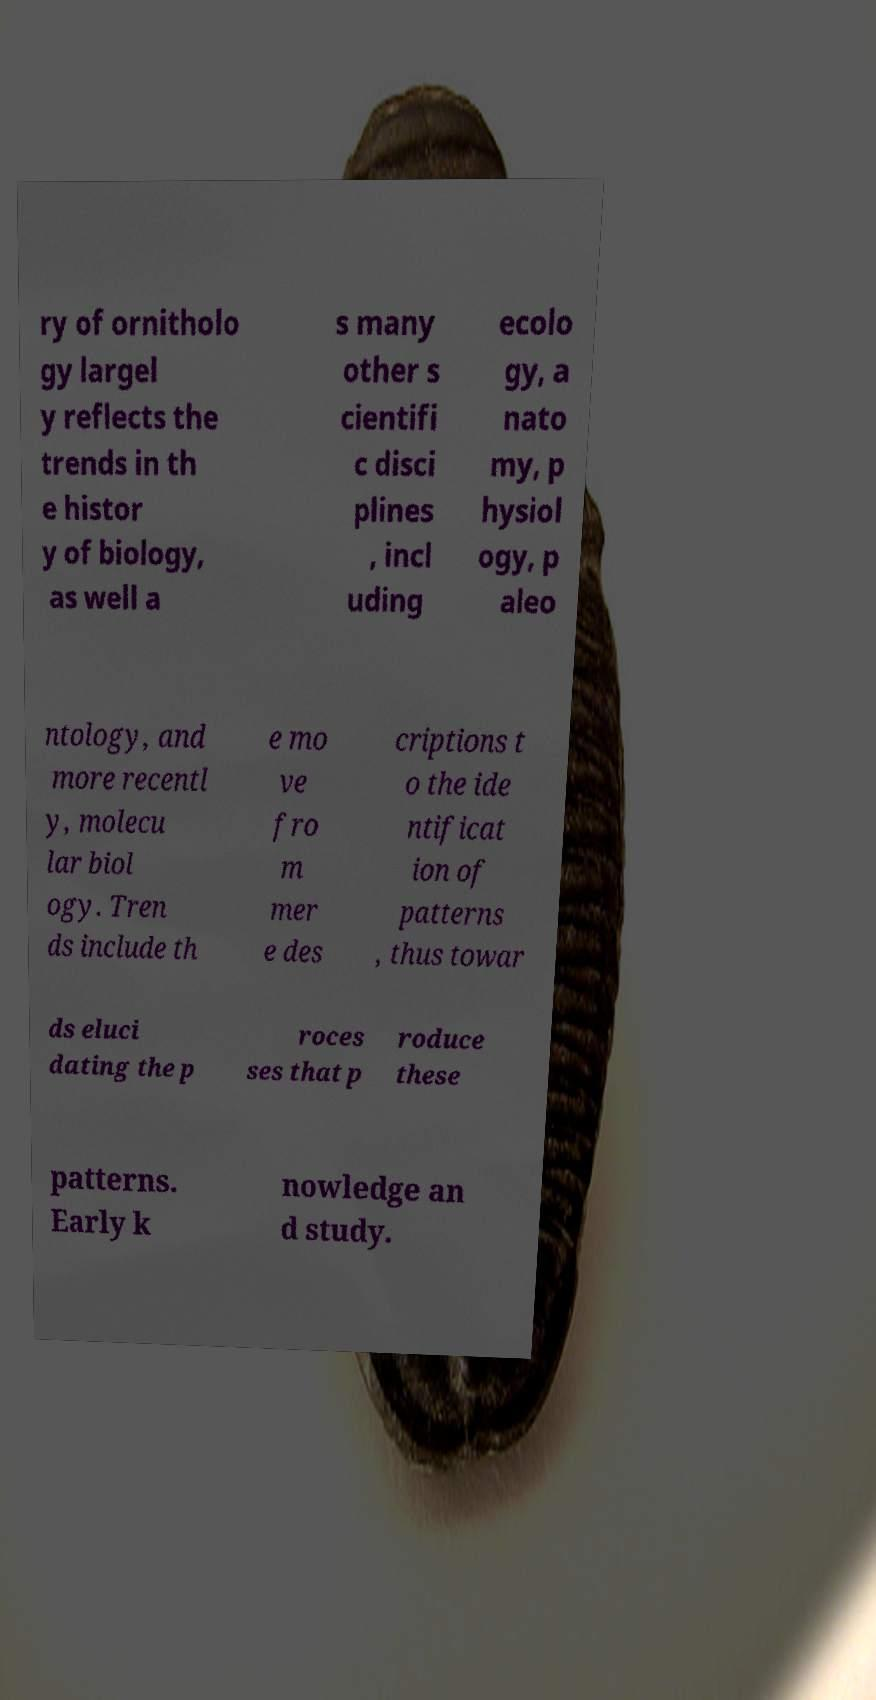For documentation purposes, I need the text within this image transcribed. Could you provide that? ry of ornitholo gy largel y reflects the trends in th e histor y of biology, as well a s many other s cientifi c disci plines , incl uding ecolo gy, a nato my, p hysiol ogy, p aleo ntology, and more recentl y, molecu lar biol ogy. Tren ds include th e mo ve fro m mer e des criptions t o the ide ntificat ion of patterns , thus towar ds eluci dating the p roces ses that p roduce these patterns. Early k nowledge an d study. 